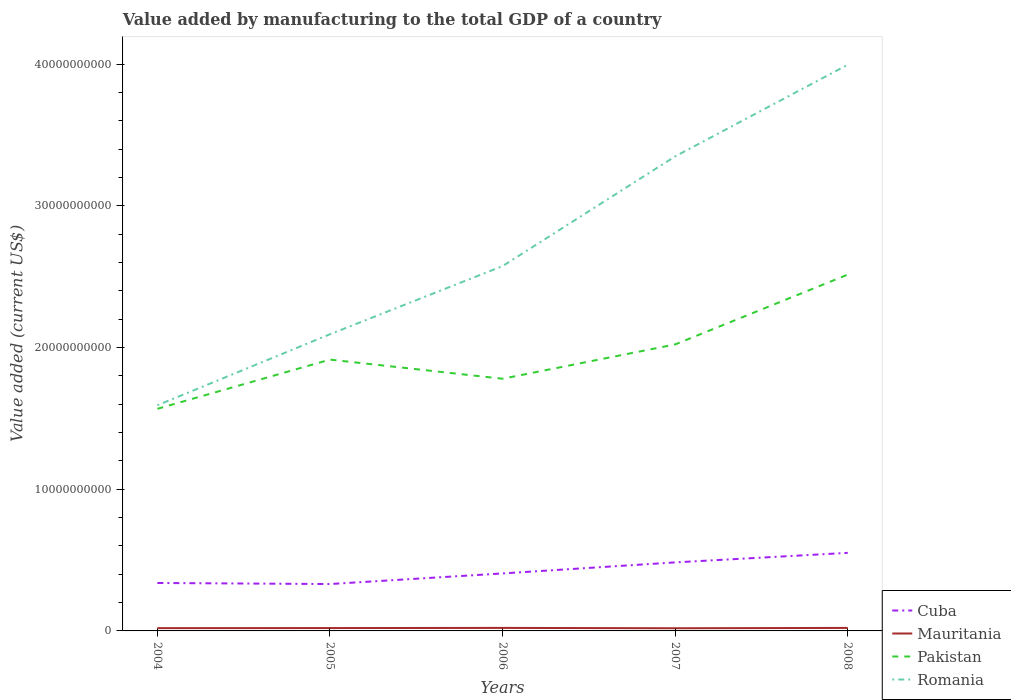Across all years, what is the maximum value added by manufacturing to the total GDP in Pakistan?
Offer a terse response. 1.57e+1. What is the total value added by manufacturing to the total GDP in Cuba in the graph?
Offer a terse response. -1.45e+09. What is the difference between the highest and the second highest value added by manufacturing to the total GDP in Pakistan?
Provide a short and direct response. 9.47e+09. What is the difference between the highest and the lowest value added by manufacturing to the total GDP in Mauritania?
Make the answer very short. 2. Is the value added by manufacturing to the total GDP in Pakistan strictly greater than the value added by manufacturing to the total GDP in Cuba over the years?
Keep it short and to the point. No. How many years are there in the graph?
Make the answer very short. 5. Does the graph contain any zero values?
Keep it short and to the point. No. Where does the legend appear in the graph?
Your answer should be very brief. Bottom right. What is the title of the graph?
Your answer should be compact. Value added by manufacturing to the total GDP of a country. Does "Sint Maarten (Dutch part)" appear as one of the legend labels in the graph?
Your answer should be very brief. No. What is the label or title of the X-axis?
Offer a terse response. Years. What is the label or title of the Y-axis?
Offer a terse response. Value added (current US$). What is the Value added (current US$) in Cuba in 2004?
Make the answer very short. 3.38e+09. What is the Value added (current US$) in Mauritania in 2004?
Offer a terse response. 1.96e+08. What is the Value added (current US$) in Pakistan in 2004?
Your answer should be very brief. 1.57e+1. What is the Value added (current US$) in Romania in 2004?
Keep it short and to the point. 1.59e+1. What is the Value added (current US$) of Cuba in 2005?
Offer a terse response. 3.31e+09. What is the Value added (current US$) of Mauritania in 2005?
Provide a succinct answer. 2.02e+08. What is the Value added (current US$) in Pakistan in 2005?
Your answer should be compact. 1.91e+1. What is the Value added (current US$) of Romania in 2005?
Ensure brevity in your answer.  2.09e+1. What is the Value added (current US$) in Cuba in 2006?
Provide a succinct answer. 4.06e+09. What is the Value added (current US$) of Mauritania in 2006?
Keep it short and to the point. 2.13e+08. What is the Value added (current US$) of Pakistan in 2006?
Keep it short and to the point. 1.78e+1. What is the Value added (current US$) in Romania in 2006?
Your answer should be compact. 2.57e+1. What is the Value added (current US$) in Cuba in 2007?
Your answer should be very brief. 4.84e+09. What is the Value added (current US$) in Mauritania in 2007?
Provide a succinct answer. 1.89e+08. What is the Value added (current US$) in Pakistan in 2007?
Your answer should be compact. 2.02e+1. What is the Value added (current US$) in Romania in 2007?
Your answer should be very brief. 3.35e+1. What is the Value added (current US$) of Cuba in 2008?
Ensure brevity in your answer.  5.51e+09. What is the Value added (current US$) of Mauritania in 2008?
Your answer should be compact. 2.11e+08. What is the Value added (current US$) of Pakistan in 2008?
Offer a very short reply. 2.51e+1. What is the Value added (current US$) of Romania in 2008?
Your answer should be very brief. 4.00e+1. Across all years, what is the maximum Value added (current US$) of Cuba?
Provide a succinct answer. 5.51e+09. Across all years, what is the maximum Value added (current US$) in Mauritania?
Your answer should be compact. 2.13e+08. Across all years, what is the maximum Value added (current US$) in Pakistan?
Ensure brevity in your answer.  2.51e+1. Across all years, what is the maximum Value added (current US$) of Romania?
Make the answer very short. 4.00e+1. Across all years, what is the minimum Value added (current US$) in Cuba?
Offer a very short reply. 3.31e+09. Across all years, what is the minimum Value added (current US$) of Mauritania?
Ensure brevity in your answer.  1.89e+08. Across all years, what is the minimum Value added (current US$) in Pakistan?
Your answer should be very brief. 1.57e+1. Across all years, what is the minimum Value added (current US$) of Romania?
Keep it short and to the point. 1.59e+1. What is the total Value added (current US$) in Cuba in the graph?
Provide a succinct answer. 2.11e+1. What is the total Value added (current US$) in Mauritania in the graph?
Provide a succinct answer. 1.01e+09. What is the total Value added (current US$) of Pakistan in the graph?
Keep it short and to the point. 9.80e+1. What is the total Value added (current US$) in Romania in the graph?
Your answer should be compact. 1.36e+11. What is the difference between the Value added (current US$) in Cuba in 2004 and that in 2005?
Offer a very short reply. 7.40e+07. What is the difference between the Value added (current US$) in Mauritania in 2004 and that in 2005?
Offer a terse response. -6.00e+06. What is the difference between the Value added (current US$) in Pakistan in 2004 and that in 2005?
Make the answer very short. -3.47e+09. What is the difference between the Value added (current US$) in Romania in 2004 and that in 2005?
Ensure brevity in your answer.  -5.01e+09. What is the difference between the Value added (current US$) in Cuba in 2004 and that in 2006?
Provide a succinct answer. -6.74e+08. What is the difference between the Value added (current US$) in Mauritania in 2004 and that in 2006?
Your answer should be compact. -1.73e+07. What is the difference between the Value added (current US$) in Pakistan in 2004 and that in 2006?
Make the answer very short. -2.12e+09. What is the difference between the Value added (current US$) of Romania in 2004 and that in 2006?
Your answer should be very brief. -9.82e+09. What is the difference between the Value added (current US$) in Cuba in 2004 and that in 2007?
Make the answer very short. -1.45e+09. What is the difference between the Value added (current US$) in Mauritania in 2004 and that in 2007?
Provide a short and direct response. 6.82e+06. What is the difference between the Value added (current US$) of Pakistan in 2004 and that in 2007?
Your answer should be very brief. -4.54e+09. What is the difference between the Value added (current US$) of Romania in 2004 and that in 2007?
Your answer should be compact. -1.76e+1. What is the difference between the Value added (current US$) of Cuba in 2004 and that in 2008?
Provide a short and direct response. -2.13e+09. What is the difference between the Value added (current US$) in Mauritania in 2004 and that in 2008?
Give a very brief answer. -1.54e+07. What is the difference between the Value added (current US$) of Pakistan in 2004 and that in 2008?
Provide a succinct answer. -9.47e+09. What is the difference between the Value added (current US$) of Romania in 2004 and that in 2008?
Provide a short and direct response. -2.40e+1. What is the difference between the Value added (current US$) in Cuba in 2005 and that in 2006?
Make the answer very short. -7.48e+08. What is the difference between the Value added (current US$) in Mauritania in 2005 and that in 2006?
Make the answer very short. -1.13e+07. What is the difference between the Value added (current US$) of Pakistan in 2005 and that in 2006?
Offer a terse response. 1.35e+09. What is the difference between the Value added (current US$) in Romania in 2005 and that in 2006?
Ensure brevity in your answer.  -4.81e+09. What is the difference between the Value added (current US$) in Cuba in 2005 and that in 2007?
Your response must be concise. -1.53e+09. What is the difference between the Value added (current US$) of Mauritania in 2005 and that in 2007?
Offer a terse response. 1.28e+07. What is the difference between the Value added (current US$) of Pakistan in 2005 and that in 2007?
Make the answer very short. -1.07e+09. What is the difference between the Value added (current US$) of Romania in 2005 and that in 2007?
Provide a succinct answer. -1.26e+1. What is the difference between the Value added (current US$) in Cuba in 2005 and that in 2008?
Ensure brevity in your answer.  -2.20e+09. What is the difference between the Value added (current US$) of Mauritania in 2005 and that in 2008?
Provide a short and direct response. -9.45e+06. What is the difference between the Value added (current US$) in Pakistan in 2005 and that in 2008?
Provide a short and direct response. -6.00e+09. What is the difference between the Value added (current US$) in Romania in 2005 and that in 2008?
Your answer should be very brief. -1.90e+1. What is the difference between the Value added (current US$) of Cuba in 2006 and that in 2007?
Keep it short and to the point. -7.80e+08. What is the difference between the Value added (current US$) in Mauritania in 2006 and that in 2007?
Keep it short and to the point. 2.42e+07. What is the difference between the Value added (current US$) of Pakistan in 2006 and that in 2007?
Provide a short and direct response. -2.42e+09. What is the difference between the Value added (current US$) of Romania in 2006 and that in 2007?
Make the answer very short. -7.74e+09. What is the difference between the Value added (current US$) in Cuba in 2006 and that in 2008?
Make the answer very short. -1.45e+09. What is the difference between the Value added (current US$) in Mauritania in 2006 and that in 2008?
Make the answer very short. 1.89e+06. What is the difference between the Value added (current US$) of Pakistan in 2006 and that in 2008?
Provide a succinct answer. -7.35e+09. What is the difference between the Value added (current US$) of Romania in 2006 and that in 2008?
Your answer should be very brief. -1.42e+1. What is the difference between the Value added (current US$) of Cuba in 2007 and that in 2008?
Your response must be concise. -6.73e+08. What is the difference between the Value added (current US$) of Mauritania in 2007 and that in 2008?
Offer a very short reply. -2.23e+07. What is the difference between the Value added (current US$) of Pakistan in 2007 and that in 2008?
Ensure brevity in your answer.  -4.93e+09. What is the difference between the Value added (current US$) of Romania in 2007 and that in 2008?
Keep it short and to the point. -6.47e+09. What is the difference between the Value added (current US$) of Cuba in 2004 and the Value added (current US$) of Mauritania in 2005?
Make the answer very short. 3.18e+09. What is the difference between the Value added (current US$) in Cuba in 2004 and the Value added (current US$) in Pakistan in 2005?
Your response must be concise. -1.58e+1. What is the difference between the Value added (current US$) in Cuba in 2004 and the Value added (current US$) in Romania in 2005?
Give a very brief answer. -1.76e+1. What is the difference between the Value added (current US$) in Mauritania in 2004 and the Value added (current US$) in Pakistan in 2005?
Ensure brevity in your answer.  -1.90e+1. What is the difference between the Value added (current US$) of Mauritania in 2004 and the Value added (current US$) of Romania in 2005?
Offer a terse response. -2.07e+1. What is the difference between the Value added (current US$) of Pakistan in 2004 and the Value added (current US$) of Romania in 2005?
Give a very brief answer. -5.26e+09. What is the difference between the Value added (current US$) in Cuba in 2004 and the Value added (current US$) in Mauritania in 2006?
Keep it short and to the point. 3.17e+09. What is the difference between the Value added (current US$) in Cuba in 2004 and the Value added (current US$) in Pakistan in 2006?
Keep it short and to the point. -1.44e+1. What is the difference between the Value added (current US$) of Cuba in 2004 and the Value added (current US$) of Romania in 2006?
Keep it short and to the point. -2.24e+1. What is the difference between the Value added (current US$) of Mauritania in 2004 and the Value added (current US$) of Pakistan in 2006?
Your response must be concise. -1.76e+1. What is the difference between the Value added (current US$) in Mauritania in 2004 and the Value added (current US$) in Romania in 2006?
Your response must be concise. -2.56e+1. What is the difference between the Value added (current US$) of Pakistan in 2004 and the Value added (current US$) of Romania in 2006?
Ensure brevity in your answer.  -1.01e+1. What is the difference between the Value added (current US$) in Cuba in 2004 and the Value added (current US$) in Mauritania in 2007?
Offer a very short reply. 3.19e+09. What is the difference between the Value added (current US$) in Cuba in 2004 and the Value added (current US$) in Pakistan in 2007?
Your answer should be compact. -1.68e+1. What is the difference between the Value added (current US$) of Cuba in 2004 and the Value added (current US$) of Romania in 2007?
Make the answer very short. -3.01e+1. What is the difference between the Value added (current US$) of Mauritania in 2004 and the Value added (current US$) of Pakistan in 2007?
Provide a succinct answer. -2.00e+1. What is the difference between the Value added (current US$) of Mauritania in 2004 and the Value added (current US$) of Romania in 2007?
Offer a very short reply. -3.33e+1. What is the difference between the Value added (current US$) in Pakistan in 2004 and the Value added (current US$) in Romania in 2007?
Offer a terse response. -1.78e+1. What is the difference between the Value added (current US$) of Cuba in 2004 and the Value added (current US$) of Mauritania in 2008?
Provide a short and direct response. 3.17e+09. What is the difference between the Value added (current US$) in Cuba in 2004 and the Value added (current US$) in Pakistan in 2008?
Your answer should be very brief. -2.18e+1. What is the difference between the Value added (current US$) of Cuba in 2004 and the Value added (current US$) of Romania in 2008?
Provide a succinct answer. -3.66e+1. What is the difference between the Value added (current US$) in Mauritania in 2004 and the Value added (current US$) in Pakistan in 2008?
Your answer should be very brief. -2.50e+1. What is the difference between the Value added (current US$) in Mauritania in 2004 and the Value added (current US$) in Romania in 2008?
Provide a succinct answer. -3.98e+1. What is the difference between the Value added (current US$) of Pakistan in 2004 and the Value added (current US$) of Romania in 2008?
Provide a succinct answer. -2.43e+1. What is the difference between the Value added (current US$) of Cuba in 2005 and the Value added (current US$) of Mauritania in 2006?
Provide a short and direct response. 3.10e+09. What is the difference between the Value added (current US$) in Cuba in 2005 and the Value added (current US$) in Pakistan in 2006?
Keep it short and to the point. -1.45e+1. What is the difference between the Value added (current US$) in Cuba in 2005 and the Value added (current US$) in Romania in 2006?
Provide a succinct answer. -2.24e+1. What is the difference between the Value added (current US$) of Mauritania in 2005 and the Value added (current US$) of Pakistan in 2006?
Keep it short and to the point. -1.76e+1. What is the difference between the Value added (current US$) of Mauritania in 2005 and the Value added (current US$) of Romania in 2006?
Your response must be concise. -2.55e+1. What is the difference between the Value added (current US$) in Pakistan in 2005 and the Value added (current US$) in Romania in 2006?
Offer a very short reply. -6.60e+09. What is the difference between the Value added (current US$) in Cuba in 2005 and the Value added (current US$) in Mauritania in 2007?
Your answer should be compact. 3.12e+09. What is the difference between the Value added (current US$) in Cuba in 2005 and the Value added (current US$) in Pakistan in 2007?
Offer a very short reply. -1.69e+1. What is the difference between the Value added (current US$) of Cuba in 2005 and the Value added (current US$) of Romania in 2007?
Keep it short and to the point. -3.02e+1. What is the difference between the Value added (current US$) in Mauritania in 2005 and the Value added (current US$) in Pakistan in 2007?
Offer a very short reply. -2.00e+1. What is the difference between the Value added (current US$) in Mauritania in 2005 and the Value added (current US$) in Romania in 2007?
Your answer should be very brief. -3.33e+1. What is the difference between the Value added (current US$) in Pakistan in 2005 and the Value added (current US$) in Romania in 2007?
Keep it short and to the point. -1.43e+1. What is the difference between the Value added (current US$) of Cuba in 2005 and the Value added (current US$) of Mauritania in 2008?
Your response must be concise. 3.10e+09. What is the difference between the Value added (current US$) of Cuba in 2005 and the Value added (current US$) of Pakistan in 2008?
Offer a terse response. -2.18e+1. What is the difference between the Value added (current US$) of Cuba in 2005 and the Value added (current US$) of Romania in 2008?
Ensure brevity in your answer.  -3.66e+1. What is the difference between the Value added (current US$) of Mauritania in 2005 and the Value added (current US$) of Pakistan in 2008?
Your answer should be very brief. -2.49e+1. What is the difference between the Value added (current US$) of Mauritania in 2005 and the Value added (current US$) of Romania in 2008?
Give a very brief answer. -3.98e+1. What is the difference between the Value added (current US$) of Pakistan in 2005 and the Value added (current US$) of Romania in 2008?
Make the answer very short. -2.08e+1. What is the difference between the Value added (current US$) of Cuba in 2006 and the Value added (current US$) of Mauritania in 2007?
Keep it short and to the point. 3.87e+09. What is the difference between the Value added (current US$) of Cuba in 2006 and the Value added (current US$) of Pakistan in 2007?
Keep it short and to the point. -1.62e+1. What is the difference between the Value added (current US$) in Cuba in 2006 and the Value added (current US$) in Romania in 2007?
Your response must be concise. -2.94e+1. What is the difference between the Value added (current US$) of Mauritania in 2006 and the Value added (current US$) of Pakistan in 2007?
Provide a short and direct response. -2.00e+1. What is the difference between the Value added (current US$) of Mauritania in 2006 and the Value added (current US$) of Romania in 2007?
Offer a very short reply. -3.33e+1. What is the difference between the Value added (current US$) in Pakistan in 2006 and the Value added (current US$) in Romania in 2007?
Ensure brevity in your answer.  -1.57e+1. What is the difference between the Value added (current US$) of Cuba in 2006 and the Value added (current US$) of Mauritania in 2008?
Give a very brief answer. 3.85e+09. What is the difference between the Value added (current US$) of Cuba in 2006 and the Value added (current US$) of Pakistan in 2008?
Your answer should be compact. -2.11e+1. What is the difference between the Value added (current US$) of Cuba in 2006 and the Value added (current US$) of Romania in 2008?
Your response must be concise. -3.59e+1. What is the difference between the Value added (current US$) in Mauritania in 2006 and the Value added (current US$) in Pakistan in 2008?
Provide a short and direct response. -2.49e+1. What is the difference between the Value added (current US$) in Mauritania in 2006 and the Value added (current US$) in Romania in 2008?
Provide a succinct answer. -3.97e+1. What is the difference between the Value added (current US$) in Pakistan in 2006 and the Value added (current US$) in Romania in 2008?
Your answer should be very brief. -2.22e+1. What is the difference between the Value added (current US$) in Cuba in 2007 and the Value added (current US$) in Mauritania in 2008?
Give a very brief answer. 4.63e+09. What is the difference between the Value added (current US$) in Cuba in 2007 and the Value added (current US$) in Pakistan in 2008?
Your answer should be very brief. -2.03e+1. What is the difference between the Value added (current US$) in Cuba in 2007 and the Value added (current US$) in Romania in 2008?
Provide a short and direct response. -3.51e+1. What is the difference between the Value added (current US$) in Mauritania in 2007 and the Value added (current US$) in Pakistan in 2008?
Offer a very short reply. -2.50e+1. What is the difference between the Value added (current US$) in Mauritania in 2007 and the Value added (current US$) in Romania in 2008?
Your answer should be very brief. -3.98e+1. What is the difference between the Value added (current US$) of Pakistan in 2007 and the Value added (current US$) of Romania in 2008?
Your answer should be very brief. -1.97e+1. What is the average Value added (current US$) in Cuba per year?
Offer a terse response. 4.22e+09. What is the average Value added (current US$) in Mauritania per year?
Provide a short and direct response. 2.02e+08. What is the average Value added (current US$) of Pakistan per year?
Your response must be concise. 1.96e+1. What is the average Value added (current US$) of Romania per year?
Provide a succinct answer. 2.72e+1. In the year 2004, what is the difference between the Value added (current US$) in Cuba and Value added (current US$) in Mauritania?
Offer a very short reply. 3.19e+09. In the year 2004, what is the difference between the Value added (current US$) of Cuba and Value added (current US$) of Pakistan?
Make the answer very short. -1.23e+1. In the year 2004, what is the difference between the Value added (current US$) of Cuba and Value added (current US$) of Romania?
Make the answer very short. -1.25e+1. In the year 2004, what is the difference between the Value added (current US$) in Mauritania and Value added (current US$) in Pakistan?
Your answer should be very brief. -1.55e+1. In the year 2004, what is the difference between the Value added (current US$) of Mauritania and Value added (current US$) of Romania?
Your response must be concise. -1.57e+1. In the year 2004, what is the difference between the Value added (current US$) of Pakistan and Value added (current US$) of Romania?
Your answer should be very brief. -2.49e+08. In the year 2005, what is the difference between the Value added (current US$) in Cuba and Value added (current US$) in Mauritania?
Keep it short and to the point. 3.11e+09. In the year 2005, what is the difference between the Value added (current US$) in Cuba and Value added (current US$) in Pakistan?
Provide a short and direct response. -1.58e+1. In the year 2005, what is the difference between the Value added (current US$) in Cuba and Value added (current US$) in Romania?
Provide a short and direct response. -1.76e+1. In the year 2005, what is the difference between the Value added (current US$) of Mauritania and Value added (current US$) of Pakistan?
Offer a very short reply. -1.89e+1. In the year 2005, what is the difference between the Value added (current US$) in Mauritania and Value added (current US$) in Romania?
Give a very brief answer. -2.07e+1. In the year 2005, what is the difference between the Value added (current US$) in Pakistan and Value added (current US$) in Romania?
Ensure brevity in your answer.  -1.79e+09. In the year 2006, what is the difference between the Value added (current US$) in Cuba and Value added (current US$) in Mauritania?
Make the answer very short. 3.84e+09. In the year 2006, what is the difference between the Value added (current US$) of Cuba and Value added (current US$) of Pakistan?
Your response must be concise. -1.37e+1. In the year 2006, what is the difference between the Value added (current US$) in Cuba and Value added (current US$) in Romania?
Your answer should be compact. -2.17e+1. In the year 2006, what is the difference between the Value added (current US$) of Mauritania and Value added (current US$) of Pakistan?
Your answer should be very brief. -1.76e+1. In the year 2006, what is the difference between the Value added (current US$) in Mauritania and Value added (current US$) in Romania?
Ensure brevity in your answer.  -2.55e+1. In the year 2006, what is the difference between the Value added (current US$) of Pakistan and Value added (current US$) of Romania?
Offer a very short reply. -7.95e+09. In the year 2007, what is the difference between the Value added (current US$) of Cuba and Value added (current US$) of Mauritania?
Your response must be concise. 4.65e+09. In the year 2007, what is the difference between the Value added (current US$) in Cuba and Value added (current US$) in Pakistan?
Offer a terse response. -1.54e+1. In the year 2007, what is the difference between the Value added (current US$) in Cuba and Value added (current US$) in Romania?
Keep it short and to the point. -2.87e+1. In the year 2007, what is the difference between the Value added (current US$) of Mauritania and Value added (current US$) of Pakistan?
Ensure brevity in your answer.  -2.00e+1. In the year 2007, what is the difference between the Value added (current US$) of Mauritania and Value added (current US$) of Romania?
Provide a short and direct response. -3.33e+1. In the year 2007, what is the difference between the Value added (current US$) in Pakistan and Value added (current US$) in Romania?
Ensure brevity in your answer.  -1.33e+1. In the year 2008, what is the difference between the Value added (current US$) in Cuba and Value added (current US$) in Mauritania?
Your response must be concise. 5.30e+09. In the year 2008, what is the difference between the Value added (current US$) in Cuba and Value added (current US$) in Pakistan?
Provide a succinct answer. -1.96e+1. In the year 2008, what is the difference between the Value added (current US$) in Cuba and Value added (current US$) in Romania?
Offer a very short reply. -3.44e+1. In the year 2008, what is the difference between the Value added (current US$) of Mauritania and Value added (current US$) of Pakistan?
Your answer should be very brief. -2.49e+1. In the year 2008, what is the difference between the Value added (current US$) of Mauritania and Value added (current US$) of Romania?
Your answer should be compact. -3.97e+1. In the year 2008, what is the difference between the Value added (current US$) in Pakistan and Value added (current US$) in Romania?
Provide a succinct answer. -1.48e+1. What is the ratio of the Value added (current US$) of Cuba in 2004 to that in 2005?
Keep it short and to the point. 1.02. What is the ratio of the Value added (current US$) of Mauritania in 2004 to that in 2005?
Provide a succinct answer. 0.97. What is the ratio of the Value added (current US$) in Pakistan in 2004 to that in 2005?
Offer a very short reply. 0.82. What is the ratio of the Value added (current US$) of Romania in 2004 to that in 2005?
Ensure brevity in your answer.  0.76. What is the ratio of the Value added (current US$) in Cuba in 2004 to that in 2006?
Your answer should be compact. 0.83. What is the ratio of the Value added (current US$) in Mauritania in 2004 to that in 2006?
Make the answer very short. 0.92. What is the ratio of the Value added (current US$) in Pakistan in 2004 to that in 2006?
Offer a terse response. 0.88. What is the ratio of the Value added (current US$) of Romania in 2004 to that in 2006?
Provide a succinct answer. 0.62. What is the ratio of the Value added (current US$) in Cuba in 2004 to that in 2007?
Offer a very short reply. 0.7. What is the ratio of the Value added (current US$) in Mauritania in 2004 to that in 2007?
Offer a very short reply. 1.04. What is the ratio of the Value added (current US$) of Pakistan in 2004 to that in 2007?
Give a very brief answer. 0.78. What is the ratio of the Value added (current US$) in Romania in 2004 to that in 2007?
Your answer should be very brief. 0.48. What is the ratio of the Value added (current US$) in Cuba in 2004 to that in 2008?
Offer a terse response. 0.61. What is the ratio of the Value added (current US$) in Mauritania in 2004 to that in 2008?
Offer a terse response. 0.93. What is the ratio of the Value added (current US$) of Pakistan in 2004 to that in 2008?
Provide a short and direct response. 0.62. What is the ratio of the Value added (current US$) of Romania in 2004 to that in 2008?
Make the answer very short. 0.4. What is the ratio of the Value added (current US$) in Cuba in 2005 to that in 2006?
Your answer should be compact. 0.82. What is the ratio of the Value added (current US$) in Mauritania in 2005 to that in 2006?
Your answer should be compact. 0.95. What is the ratio of the Value added (current US$) in Pakistan in 2005 to that in 2006?
Offer a very short reply. 1.08. What is the ratio of the Value added (current US$) in Romania in 2005 to that in 2006?
Make the answer very short. 0.81. What is the ratio of the Value added (current US$) of Cuba in 2005 to that in 2007?
Offer a terse response. 0.68. What is the ratio of the Value added (current US$) in Mauritania in 2005 to that in 2007?
Provide a succinct answer. 1.07. What is the ratio of the Value added (current US$) in Pakistan in 2005 to that in 2007?
Your answer should be very brief. 0.95. What is the ratio of the Value added (current US$) in Romania in 2005 to that in 2007?
Offer a very short reply. 0.63. What is the ratio of the Value added (current US$) in Cuba in 2005 to that in 2008?
Provide a short and direct response. 0.6. What is the ratio of the Value added (current US$) of Mauritania in 2005 to that in 2008?
Keep it short and to the point. 0.96. What is the ratio of the Value added (current US$) in Pakistan in 2005 to that in 2008?
Provide a succinct answer. 0.76. What is the ratio of the Value added (current US$) of Romania in 2005 to that in 2008?
Your answer should be very brief. 0.52. What is the ratio of the Value added (current US$) of Cuba in 2006 to that in 2007?
Offer a terse response. 0.84. What is the ratio of the Value added (current US$) of Mauritania in 2006 to that in 2007?
Keep it short and to the point. 1.13. What is the ratio of the Value added (current US$) of Pakistan in 2006 to that in 2007?
Provide a succinct answer. 0.88. What is the ratio of the Value added (current US$) of Romania in 2006 to that in 2007?
Provide a short and direct response. 0.77. What is the ratio of the Value added (current US$) in Cuba in 2006 to that in 2008?
Give a very brief answer. 0.74. What is the ratio of the Value added (current US$) in Mauritania in 2006 to that in 2008?
Your response must be concise. 1.01. What is the ratio of the Value added (current US$) of Pakistan in 2006 to that in 2008?
Your answer should be very brief. 0.71. What is the ratio of the Value added (current US$) of Romania in 2006 to that in 2008?
Give a very brief answer. 0.64. What is the ratio of the Value added (current US$) of Cuba in 2007 to that in 2008?
Offer a very short reply. 0.88. What is the ratio of the Value added (current US$) of Mauritania in 2007 to that in 2008?
Offer a very short reply. 0.89. What is the ratio of the Value added (current US$) of Pakistan in 2007 to that in 2008?
Offer a very short reply. 0.8. What is the ratio of the Value added (current US$) in Romania in 2007 to that in 2008?
Your response must be concise. 0.84. What is the difference between the highest and the second highest Value added (current US$) of Cuba?
Offer a very short reply. 6.73e+08. What is the difference between the highest and the second highest Value added (current US$) of Mauritania?
Ensure brevity in your answer.  1.89e+06. What is the difference between the highest and the second highest Value added (current US$) in Pakistan?
Give a very brief answer. 4.93e+09. What is the difference between the highest and the second highest Value added (current US$) of Romania?
Provide a short and direct response. 6.47e+09. What is the difference between the highest and the lowest Value added (current US$) of Cuba?
Provide a short and direct response. 2.20e+09. What is the difference between the highest and the lowest Value added (current US$) in Mauritania?
Provide a succinct answer. 2.42e+07. What is the difference between the highest and the lowest Value added (current US$) in Pakistan?
Ensure brevity in your answer.  9.47e+09. What is the difference between the highest and the lowest Value added (current US$) in Romania?
Your answer should be very brief. 2.40e+1. 